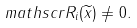<formula> <loc_0><loc_0><loc_500><loc_500>\ m a t h s c r { R } _ { i } ( \widetilde { x } ) \neq 0 .</formula> 